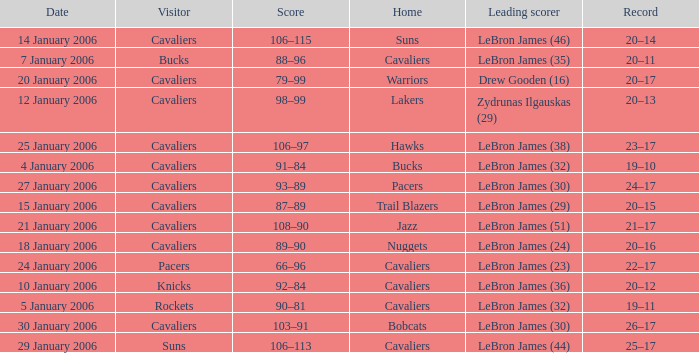Who was the leading score in the game at the Warriors? Drew Gooden (16). 